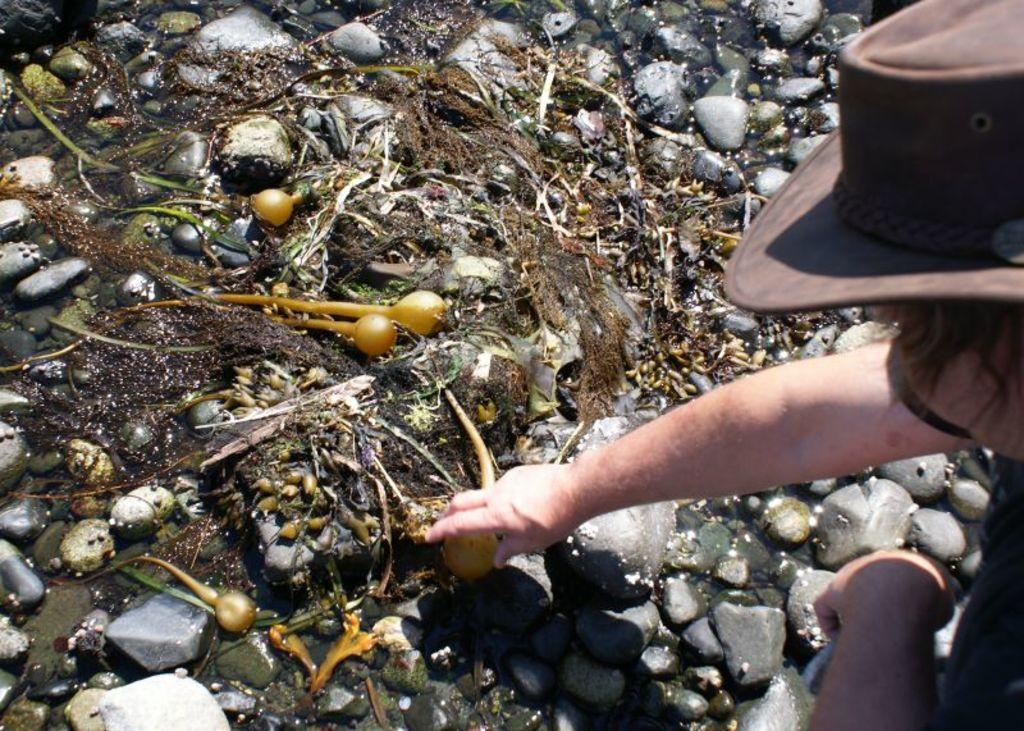In one or two sentences, can you explain what this image depicts? In a given image I can see a stones and towards right, I can see a person wearing a cap. 